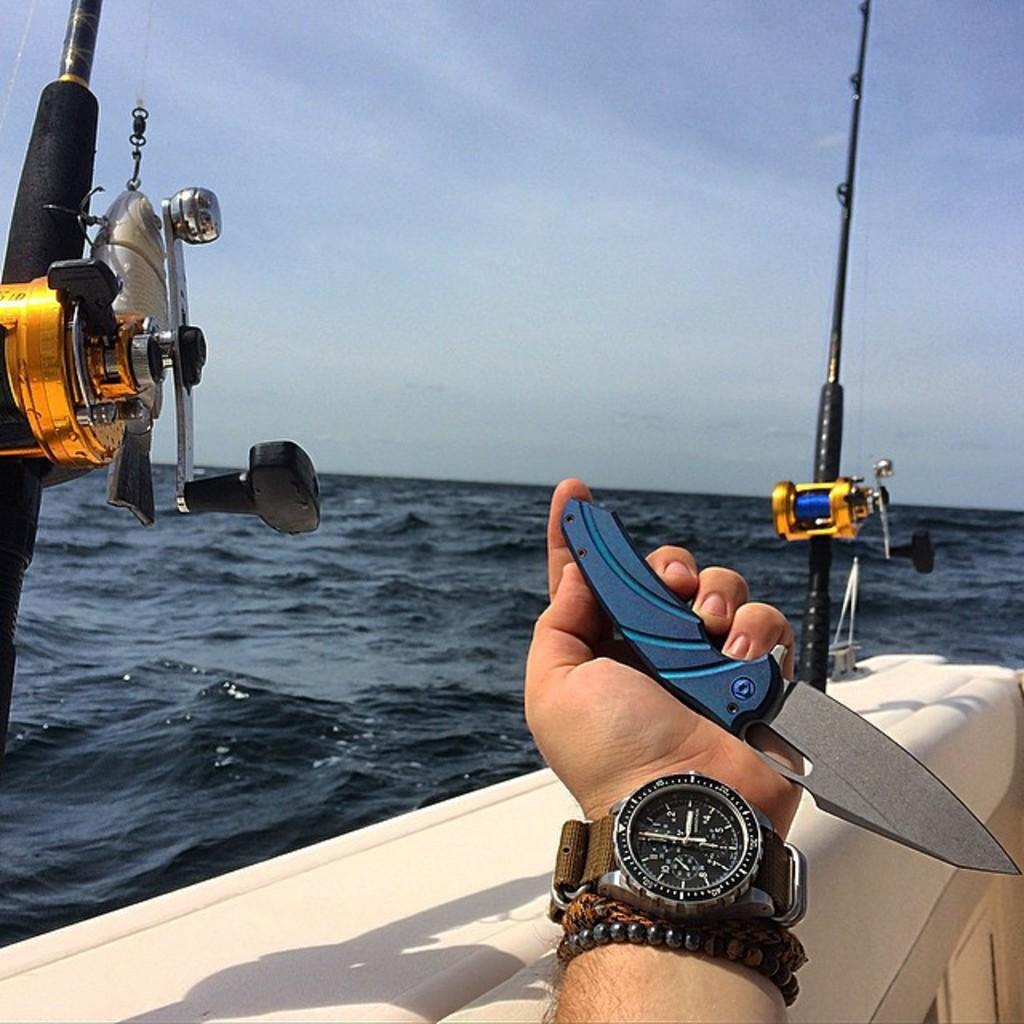<image>
Write a terse but informative summary of the picture. a man is holding a knife while wearing a watch that says it is 3 o clock. 